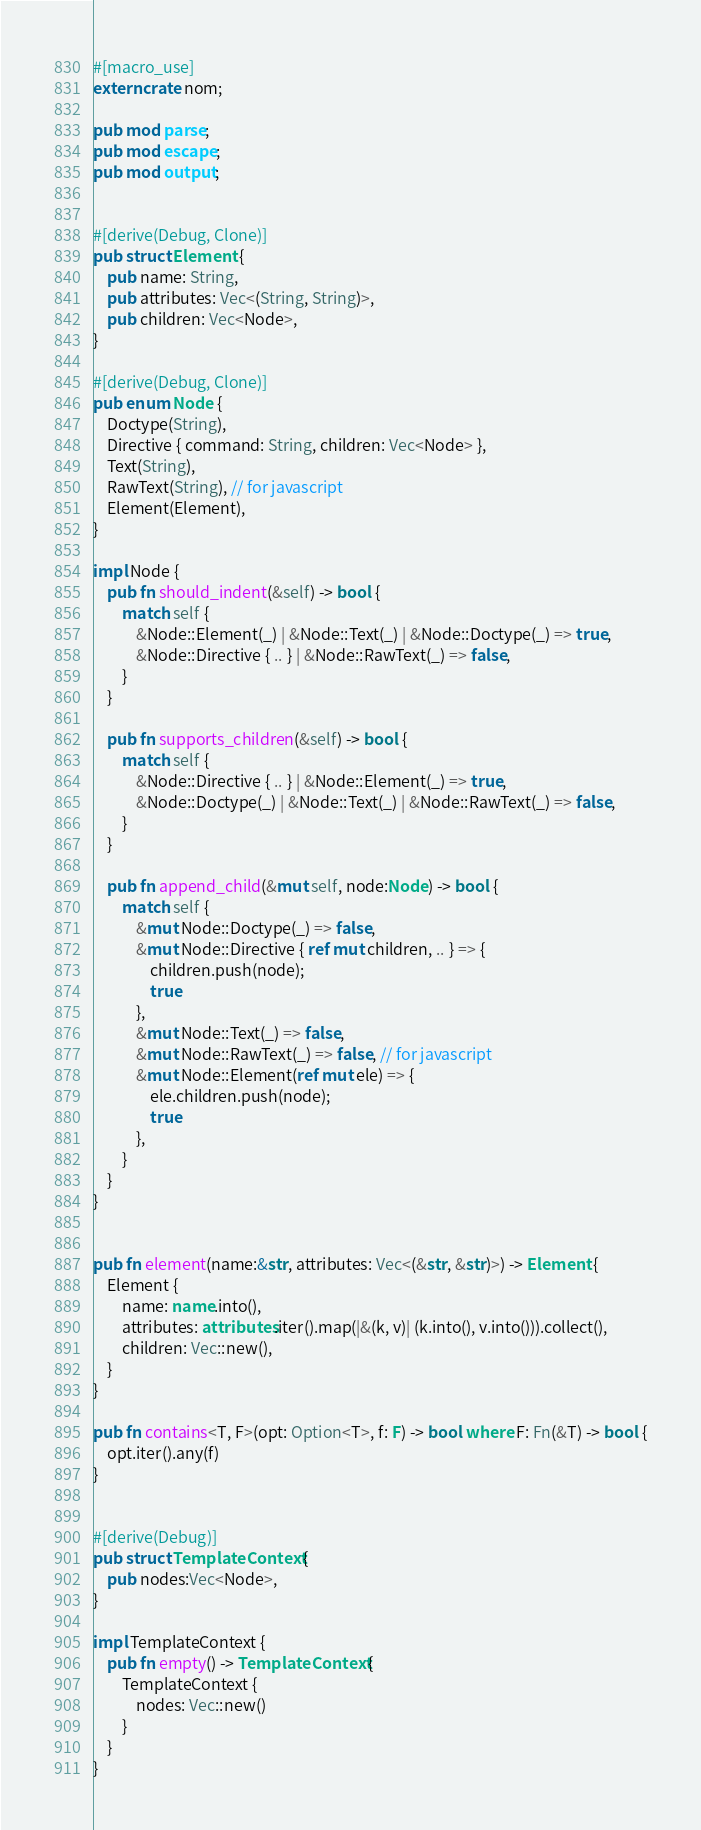Convert code to text. <code><loc_0><loc_0><loc_500><loc_500><_Rust_>#[macro_use]
extern crate nom;

pub mod parse;
pub mod escape;
pub mod output;


#[derive(Debug, Clone)]
pub struct Element {
    pub name: String,
    pub attributes: Vec<(String, String)>,
    pub children: Vec<Node>,
}

#[derive(Debug, Clone)]
pub enum Node {
    Doctype(String),
    Directive { command: String, children: Vec<Node> },
    Text(String),
    RawText(String), // for javascript
    Element(Element),
}

impl Node {
    pub fn should_indent(&self) -> bool {
        match self {
            &Node::Element(_) | &Node::Text(_) | &Node::Doctype(_) => true,
            &Node::Directive { .. } | &Node::RawText(_) => false,
        }
    }

    pub fn supports_children(&self) -> bool {
        match self {
            &Node::Directive { .. } | &Node::Element(_) => true,
            &Node::Doctype(_) | &Node::Text(_) | &Node::RawText(_) => false,
        }
    }

    pub fn append_child(&mut self, node:Node) -> bool {
        match self {
            &mut Node::Doctype(_) => false,
            &mut Node::Directive { ref mut children, .. } => {
                children.push(node);
                true
            },
            &mut Node::Text(_) => false,
            &mut Node::RawText(_) => false, // for javascript
            &mut Node::Element(ref mut ele) => {
                ele.children.push(node);
                true
            },
        }
    }
}


pub fn element(name:&str, attributes: Vec<(&str, &str)>) -> Element {
    Element {
        name: name.into(),
        attributes: attributes.iter().map(|&(k, v)| (k.into(), v.into())).collect(),
        children: Vec::new(),
    }
}

pub fn contains<T, F>(opt: Option<T>, f: F) -> bool where F: Fn(&T) -> bool {
    opt.iter().any(f)
}


#[derive(Debug)]
pub struct TemplateContext {
    pub nodes:Vec<Node>,
}

impl TemplateContext {
    pub fn empty() -> TemplateContext {
        TemplateContext {
            nodes: Vec::new()
        }
    }
}</code> 